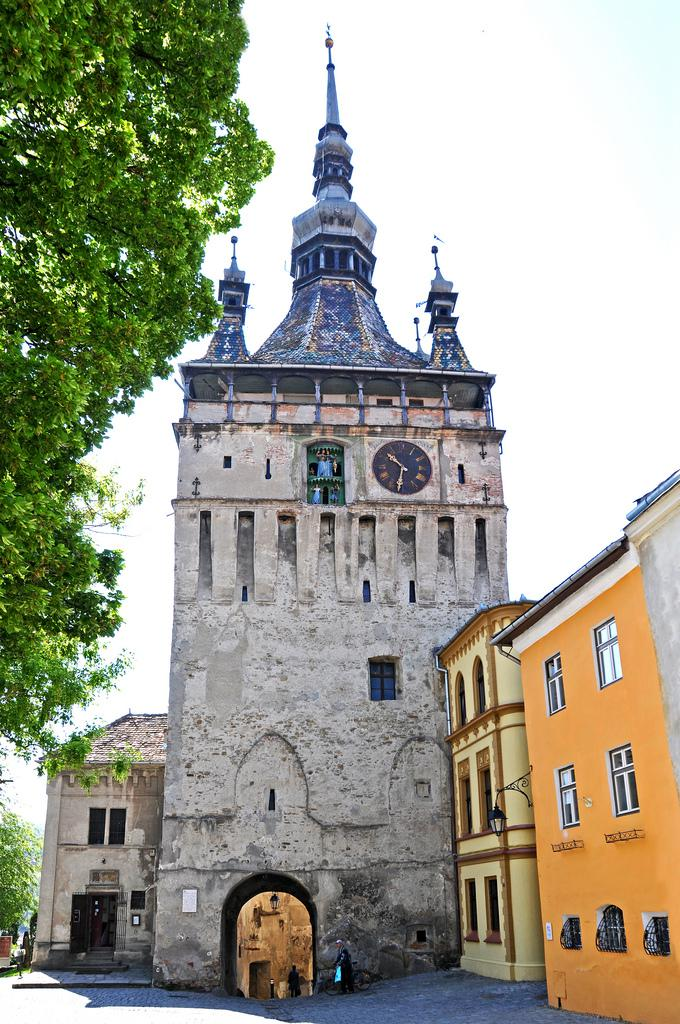Question: what has the clock at the top?
Choices:
A. The bank.
B. Historical building.
C. The church.
D. The town hall.
Answer with the letter. Answer: B Question: where was this picture taken?
Choices:
A. In front of the store.
B. In front of an old building.
C. In front of the building that recently closed.
D. In front of a historical building.
Answer with the letter. Answer: B Question: where was this photo taken?
Choices:
A. On a beach.
B. At the lakeshore.
C. On a street.
D. In the park.
Answer with the letter. Answer: C Question: what was built around the ancient tower?
Choices:
A. Temples.
B. Newer buildings.
C. Shrines.
D. Homes.
Answer with the letter. Answer: B Question: what is covering the roof?
Choices:
A. Shingles.
B. Slate roofing.
C. Tin.
D. Appears to be mosaic.
Answer with the letter. Answer: D Question: what time does the clock read?
Choices:
A. High noon.
B. Approximately 10:31.
C. Seven o'clock.
D. 6:56 am.
Answer with the letter. Answer: B Question: how many yellow buildings are there?
Choices:
A. Three.
B. Four.
C. Five.
D. Two.
Answer with the letter. Answer: D Question: what are the walkways made of?
Choices:
A. Brick.
B. Dirt.
C. Cobblestone.
D. Grass.
Answer with the letter. Answer: C Question: what type of buildings are yellow?
Choices:
A. Warehouses.
B. Looks like homes.
C. Office buildings.
D. Apartment complex.
Answer with the letter. Answer: B 